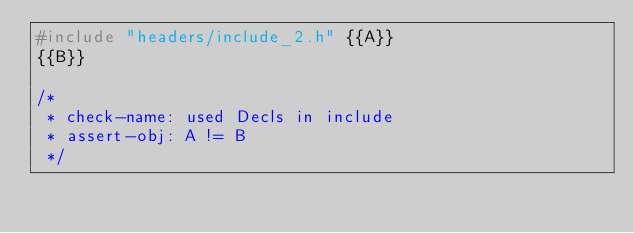<code> <loc_0><loc_0><loc_500><loc_500><_C_>#include "headers/include_2.h" {{A}}
{{B}}

/*
 * check-name: used Decls in include
 * assert-obj: A != B
 */
</code> 